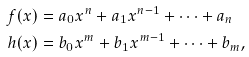Convert formula to latex. <formula><loc_0><loc_0><loc_500><loc_500>f ( x ) & = a _ { 0 } x ^ { n } + a _ { 1 } x ^ { n - 1 } + \dots + a _ { n } \\ h ( x ) & = b _ { 0 } x ^ { m } + b _ { 1 } x ^ { m - 1 } + \dots + b _ { m } ,</formula> 